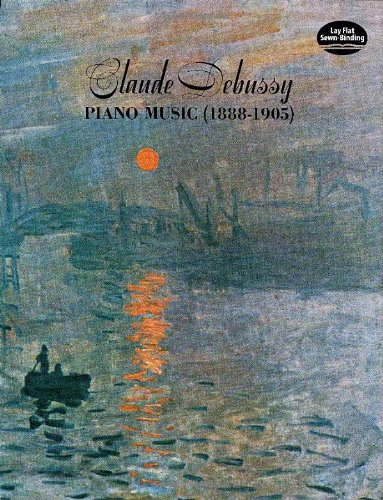What is the title of this book? The title of the book is 'Claude Debussy: Piano Music (1888-1905)', which encompasses a selection of Debussy's compositions from those years, reflecting his creative evolution. 